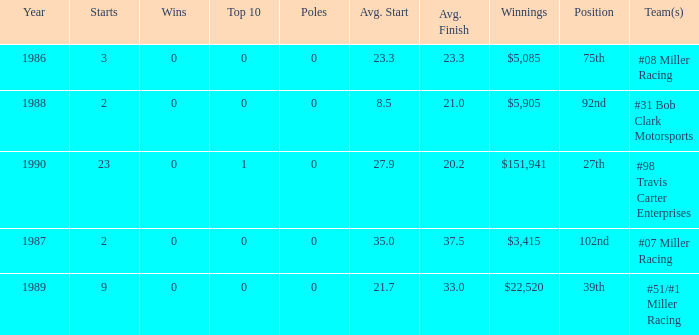What racing team/s had the 92nd position? #31 Bob Clark Motorsports. 